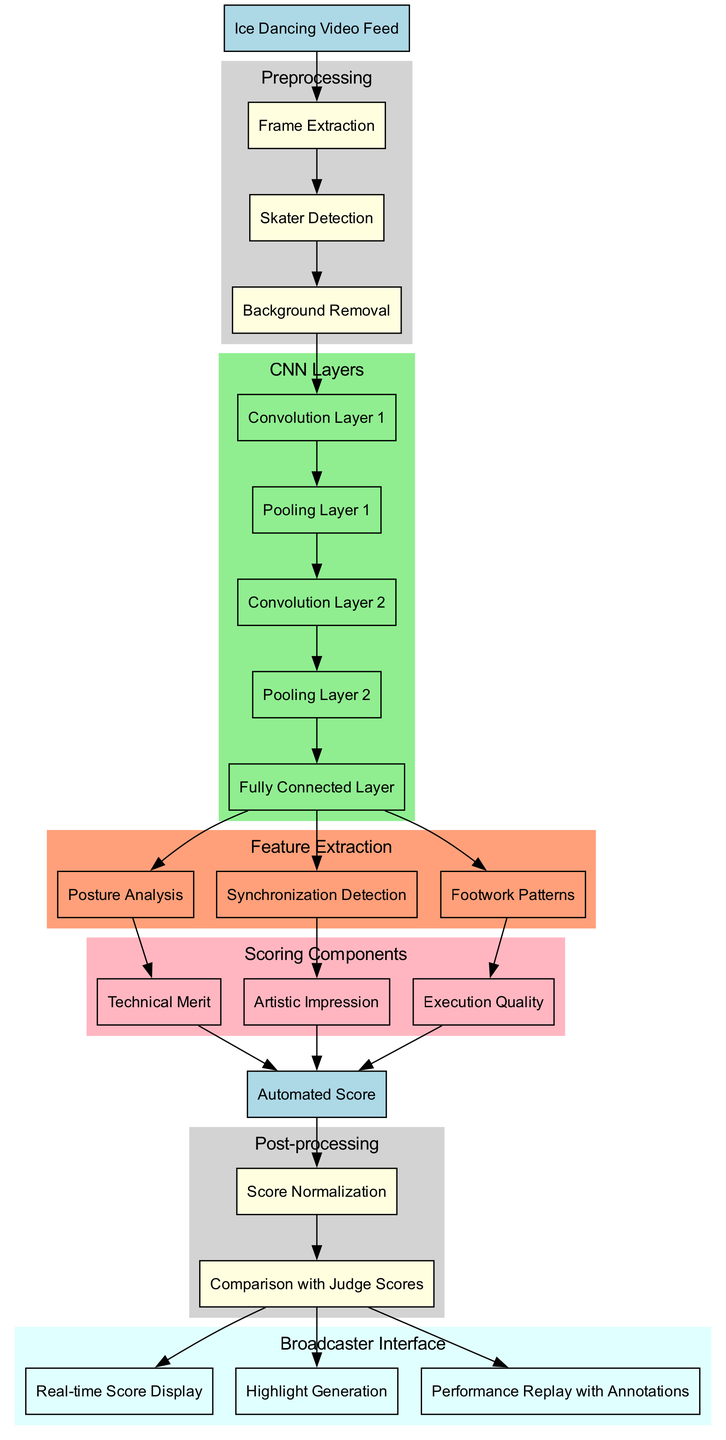What is the input of the CNN scoring system? The diagram clearly identifies 'Ice Dancing Video Feed' as the initial input node, which is where the process begins.
Answer: Ice Dancing Video Feed How many preprocessing steps are there? By counting the nodes in the preprocessing subgraph, we see there are three distinct steps listed; 'Frame Extraction', 'Skater Detection', and 'Background Removal'.
Answer: 3 What is the third CNN layer? The CNN layers are sequentially numbered in the diagram; the third layer mentioned is 'Convolution Layer 2', which is the node marked with the index 1 in the chain of layers.
Answer: Convolution Layer 2 List one component of scoring. The scoring components subgraph includes three distinct components, and one of them is 'Technical Merit', which is the first node listed in the scoring section.
Answer: Technical Merit What comes after scoring components in the flow? Following the scoring components in the flow of the diagram, the next logical step is the output node, which aggregates the results from the scoring components.
Answer: Automated Score Which feature is analyzed last? The feature extraction part of the diagram includes three features, and the last listed is 'Footwork Patterns', indicating that this is the last feature considered in extraction.
Answer: Footwork Patterns What is the output of the post-processing phase? The final node of the post-processing section leads to the broadcaster interface, and the output after all processing is labeled clearly as 'Automated Score', which summarizes what was processed.
Answer: Automated Score Which preprocessing step is first? The first step in the preprocessing subgraph is 'Frame Extraction', which starts the initial operations before proceeding to detect skaters and remove backgrounds.
Answer: Frame Extraction How many features are extracted from the CNN layers? The feature extraction section mentions three features derived from the CNN layers, indicating that the process identifies multiple characteristics of the ice dancing performances.
Answer: 3 